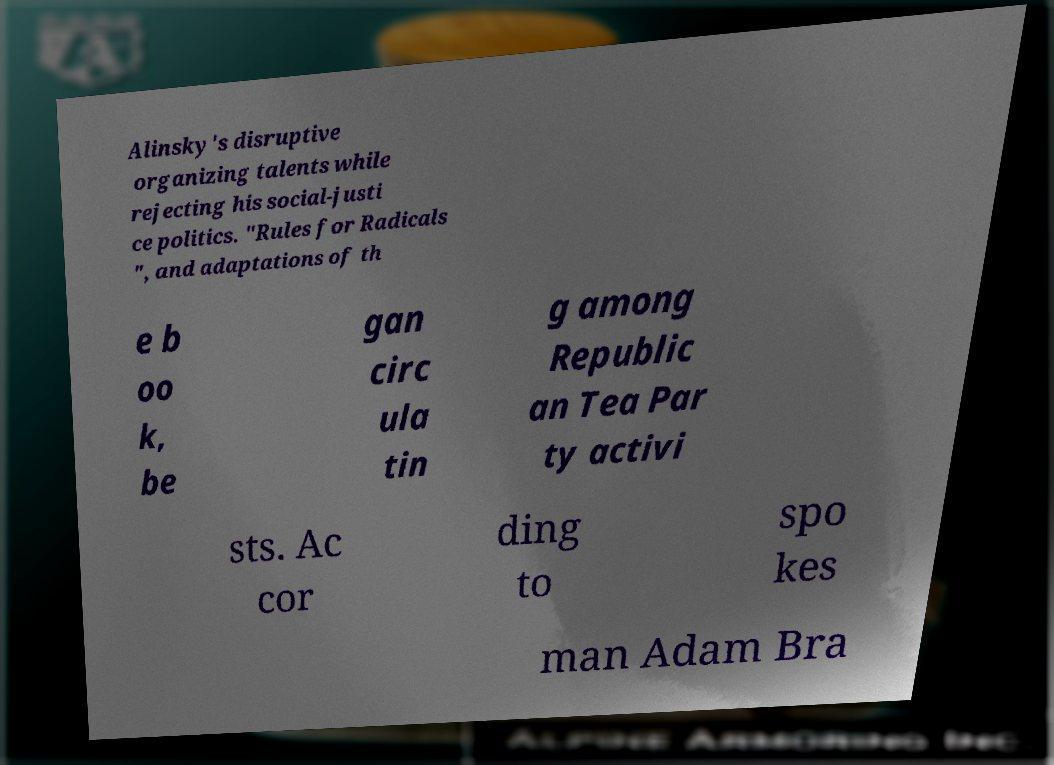Could you extract and type out the text from this image? Alinsky's disruptive organizing talents while rejecting his social-justi ce politics. "Rules for Radicals ", and adaptations of th e b oo k, be gan circ ula tin g among Republic an Tea Par ty activi sts. Ac cor ding to spo kes man Adam Bra 